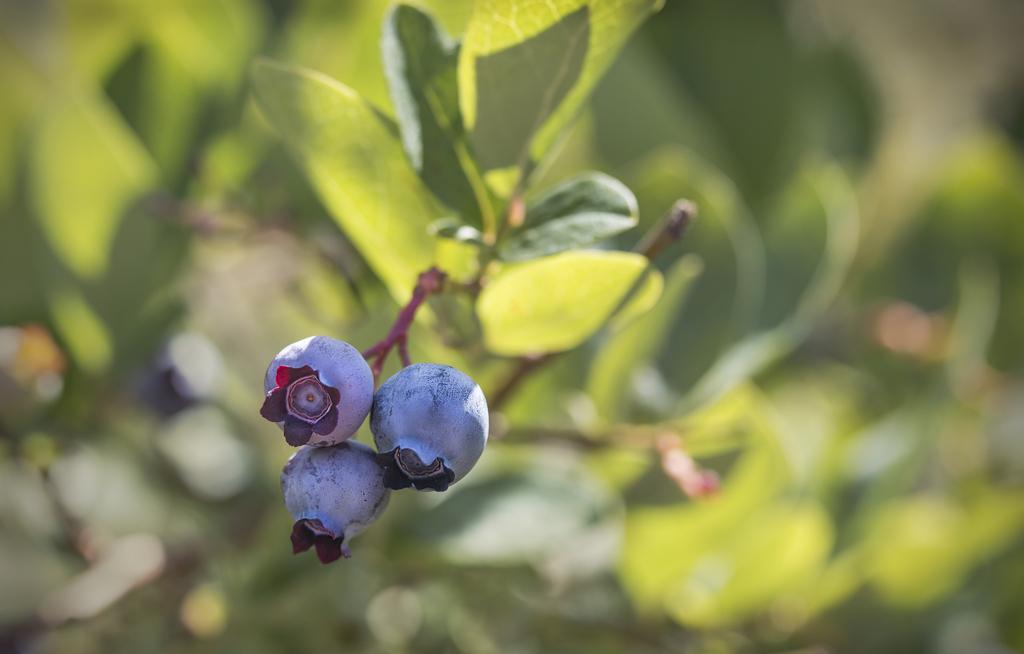In one or two sentences, can you explain what this image depicts? In this image there is a plant, there are three blueberry fruits, the background of the image is blurred. 